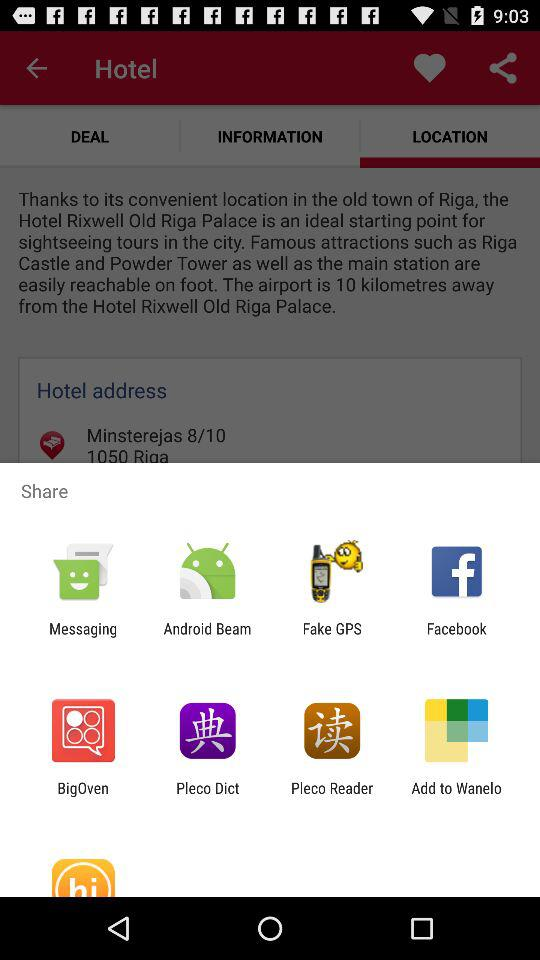Which is the selected tab? The selected tab is "LOCATION". 